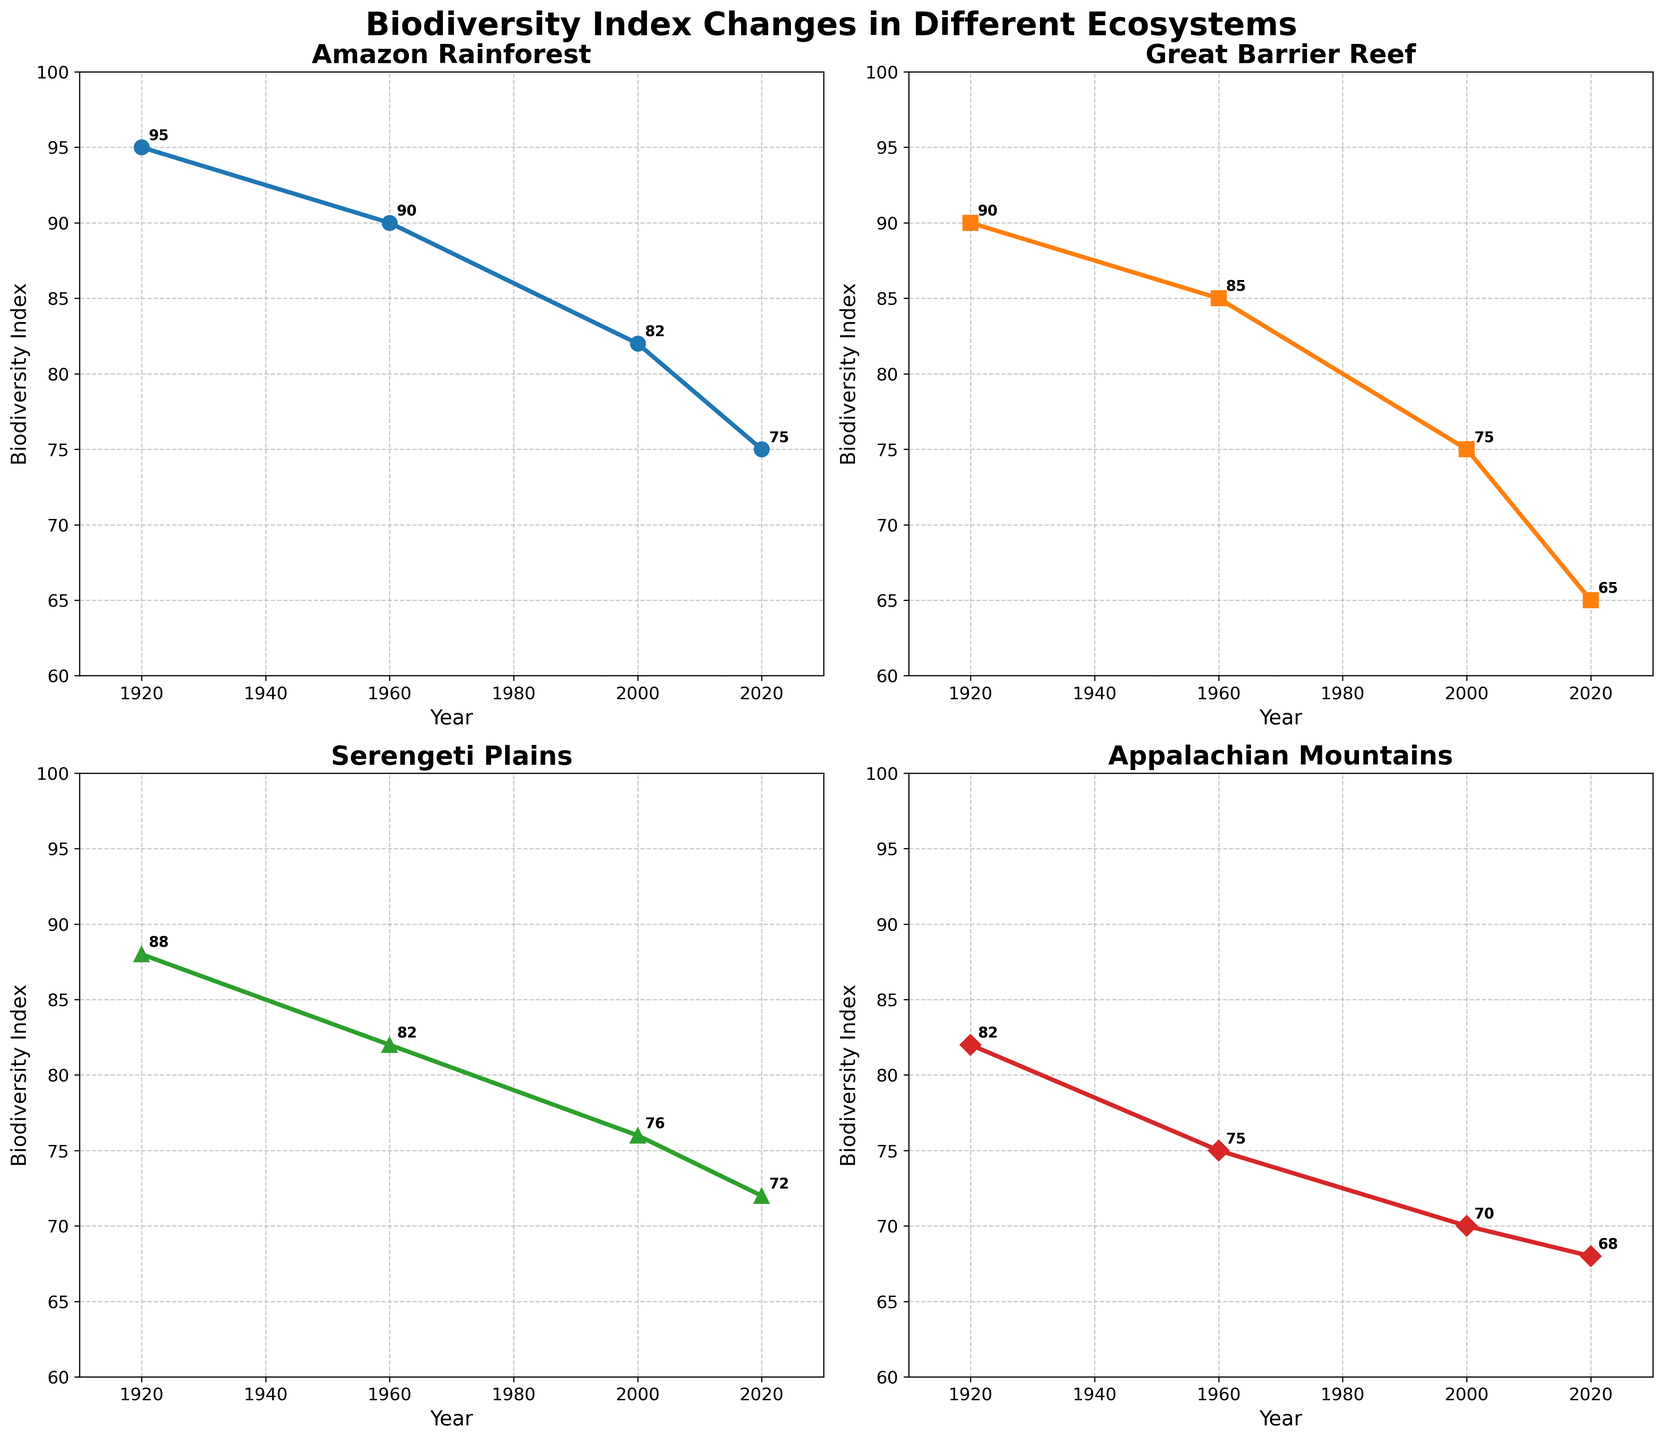What are the biodiversity index values for the Amazon Rainforest in 1920 and 2020? The values for the Amazon Rainforest in the subplot are marked as 95 in 1920 and 75 in 2020.
Answer: 95 and 75 Which ecosystem had the highest biodiversity index in 1960? In the subplot for 1960, the ecosystem with the highest biodiversity index is the Amazon Rainforest at 90.
Answer: Amazon Rainforest What's the difference in biodiversity index for the Appalachian Mountains between 1920 and 2020? The biodiversity indices for the Appalachian Mountains in 1920 and 2020 are 82 and 68, respectively. The difference is 82 - 68 = 14.
Answer: 14 Which ecosystems have seen the greatest and the least decline in biodiversity index from 1920 to 2020? From the subplots, the Great Barrier Reef declined from 90 to 65 (25 points), and the Appalachian Mountains declined from 82 to 68 (14 points), making the Great Barrier Reef the greatest decline. The Serengeti Plains declined from 88 to 72 (16 points), which is the least decline.
Answer: Greatest: Great Barrier Reef, Least: Appalachian Mountains How did the biodiversity index of the Serengeti Plains change from 1960 to 2000? For the Serengeti Plains, the biodiversity index decreased from 82 in 1960 to 76 in 2000, resulting in a decrease of 82 - 76 = 6 points.
Answer: Decreased by 6 points Between 1960 and 2000, did any ecosystem see an increase in their biodiversity index? From the subplots, all ecosystems show a decline in their biodiversity indices between 1960 and 2000.
Answer: No By how many points did the biodiversity index of the Great Barrier Reef fall from 1920 to 2000? The biodiversity index for the Great Barrier Reef fell from 90 in 1920 to 75 in 2000. The decline is 90 - 75 = 15 points.
Answer: 15 points What's the average biodiversity index across all the ecosystems in 2020? In 2020, the biodiversity indices are 75 (Amazon Rainforest), 65 (Great Barrier Reef), 72 (Serengeti Plains), and 68 (Appalachian Mountains). The average is (75 + 65 + 72 + 68) / 4 = 70.
Answer: 70 Which ecosystem had the smallest decline in biodiversity index between 1960 and 2020? From the subplots, the Appalachian Mountains had a decline from 75 in 1960 to 68 in 2020, the smallest decline of 7 points.
Answer: Appalachian Mountains 